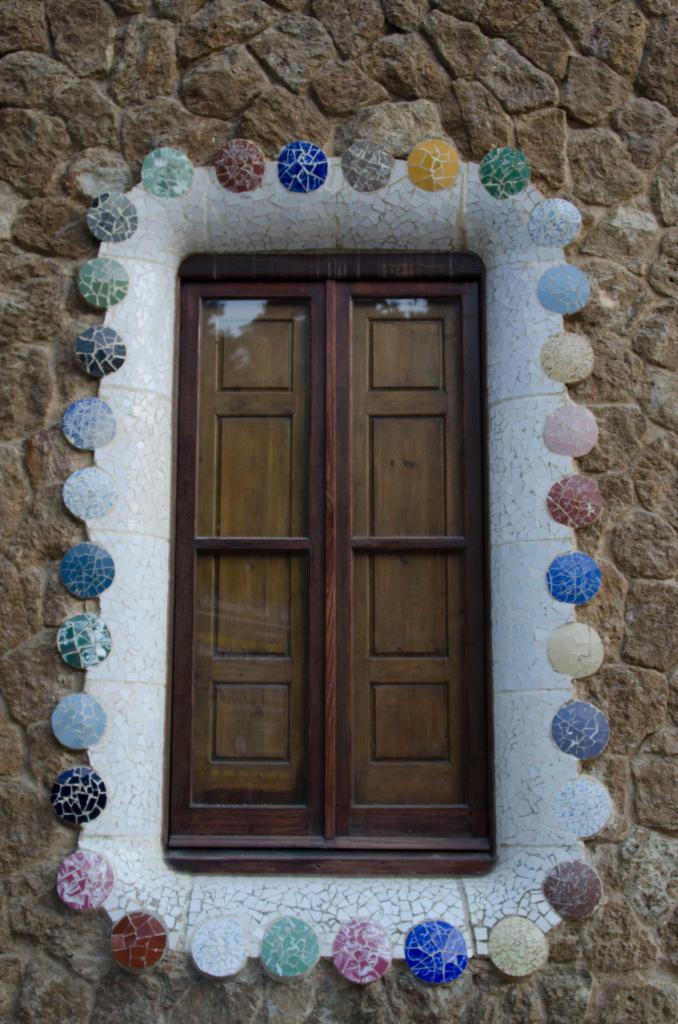In one or two sentences, can you explain what this image depicts? In the picture I can see a glass door which has few decorative objects of different colors around it on a brick wall. 